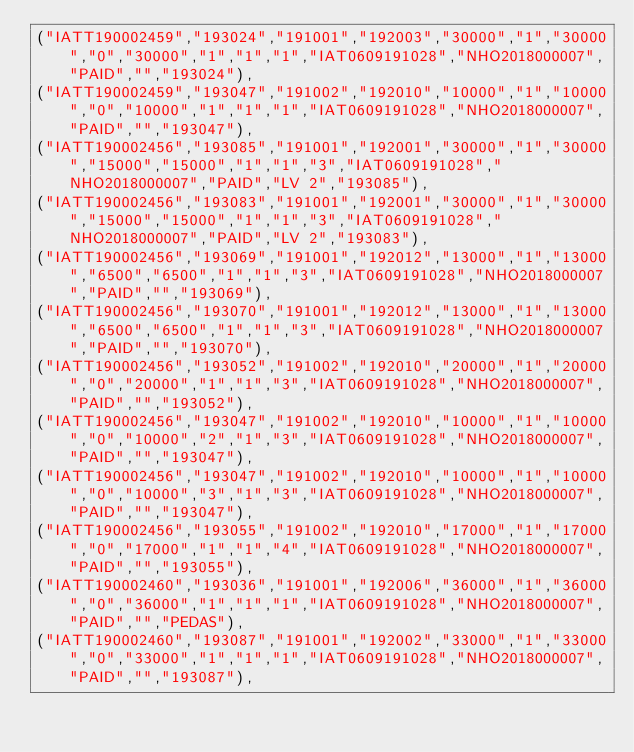<code> <loc_0><loc_0><loc_500><loc_500><_SQL_>("IATT190002459","193024","191001","192003","30000","1","30000","0","30000","1","1","1","IAT0609191028","NHO2018000007","PAID","","193024"),
("IATT190002459","193047","191002","192010","10000","1","10000","0","10000","1","1","1","IAT0609191028","NHO2018000007","PAID","","193047"),
("IATT190002456","193085","191001","192001","30000","1","30000","15000","15000","1","1","3","IAT0609191028","NHO2018000007","PAID","LV 2","193085"),
("IATT190002456","193083","191001","192001","30000","1","30000","15000","15000","1","1","3","IAT0609191028","NHO2018000007","PAID","LV 2","193083"),
("IATT190002456","193069","191001","192012","13000","1","13000","6500","6500","1","1","3","IAT0609191028","NHO2018000007","PAID","","193069"),
("IATT190002456","193070","191001","192012","13000","1","13000","6500","6500","1","1","3","IAT0609191028","NHO2018000007","PAID","","193070"),
("IATT190002456","193052","191002","192010","20000","1","20000","0","20000","1","1","3","IAT0609191028","NHO2018000007","PAID","","193052"),
("IATT190002456","193047","191002","192010","10000","1","10000","0","10000","2","1","3","IAT0609191028","NHO2018000007","PAID","","193047"),
("IATT190002456","193047","191002","192010","10000","1","10000","0","10000","3","1","3","IAT0609191028","NHO2018000007","PAID","","193047"),
("IATT190002456","193055","191002","192010","17000","1","17000","0","17000","1","1","4","IAT0609191028","NHO2018000007","PAID","","193055"),
("IATT190002460","193036","191001","192006","36000","1","36000","0","36000","1","1","1","IAT0609191028","NHO2018000007","PAID","","PEDAS"),
("IATT190002460","193087","191001","192002","33000","1","33000","0","33000","1","1","1","IAT0609191028","NHO2018000007","PAID","","193087"),</code> 